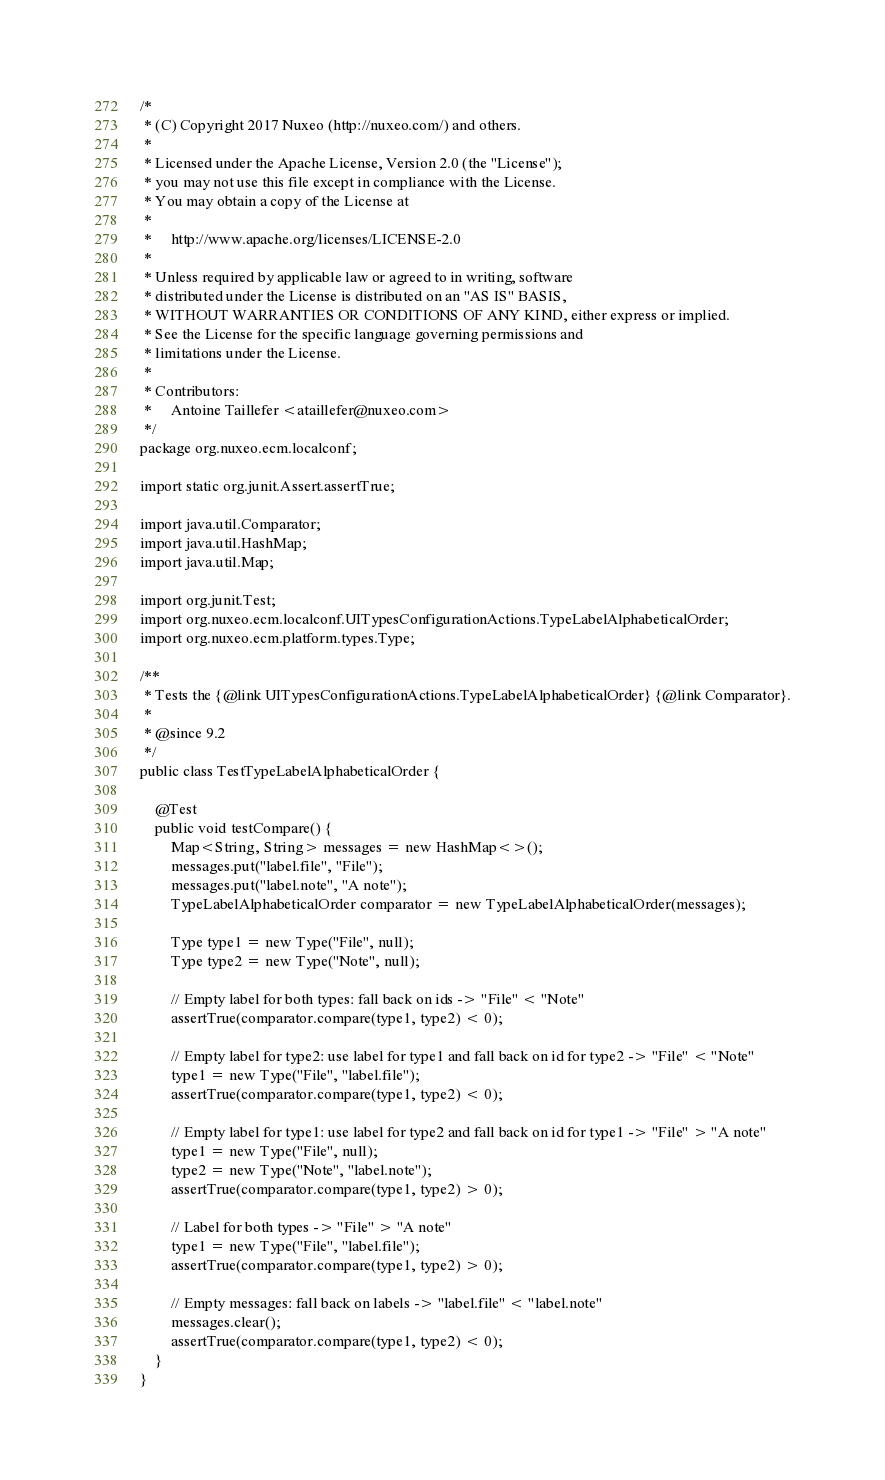<code> <loc_0><loc_0><loc_500><loc_500><_Java_>/*
 * (C) Copyright 2017 Nuxeo (http://nuxeo.com/) and others.
 *
 * Licensed under the Apache License, Version 2.0 (the "License");
 * you may not use this file except in compliance with the License.
 * You may obtain a copy of the License at
 *
 *     http://www.apache.org/licenses/LICENSE-2.0
 *
 * Unless required by applicable law or agreed to in writing, software
 * distributed under the License is distributed on an "AS IS" BASIS,
 * WITHOUT WARRANTIES OR CONDITIONS OF ANY KIND, either express or implied.
 * See the License for the specific language governing permissions and
 * limitations under the License.
 *
 * Contributors:
 *     Antoine Taillefer <ataillefer@nuxeo.com>
 */
package org.nuxeo.ecm.localconf;

import static org.junit.Assert.assertTrue;

import java.util.Comparator;
import java.util.HashMap;
import java.util.Map;

import org.junit.Test;
import org.nuxeo.ecm.localconf.UITypesConfigurationActions.TypeLabelAlphabeticalOrder;
import org.nuxeo.ecm.platform.types.Type;

/**
 * Tests the {@link UITypesConfigurationActions.TypeLabelAlphabeticalOrder} {@link Comparator}.
 *
 * @since 9.2
 */
public class TestTypeLabelAlphabeticalOrder {

    @Test
    public void testCompare() {
        Map<String, String> messages = new HashMap<>();
        messages.put("label.file", "File");
        messages.put("label.note", "A note");
        TypeLabelAlphabeticalOrder comparator = new TypeLabelAlphabeticalOrder(messages);

        Type type1 = new Type("File", null);
        Type type2 = new Type("Note", null);

        // Empty label for both types: fall back on ids -> "File" < "Note"
        assertTrue(comparator.compare(type1, type2) < 0);

        // Empty label for type2: use label for type1 and fall back on id for type2 -> "File" < "Note"
        type1 = new Type("File", "label.file");
        assertTrue(comparator.compare(type1, type2) < 0);

        // Empty label for type1: use label for type2 and fall back on id for type1 -> "File" > "A note"
        type1 = new Type("File", null);
        type2 = new Type("Note", "label.note");
        assertTrue(comparator.compare(type1, type2) > 0);

        // Label for both types -> "File" > "A note"
        type1 = new Type("File", "label.file");
        assertTrue(comparator.compare(type1, type2) > 0);

        // Empty messages: fall back on labels -> "label.file" < "label.note"
        messages.clear();
        assertTrue(comparator.compare(type1, type2) < 0);
    }
}
</code> 